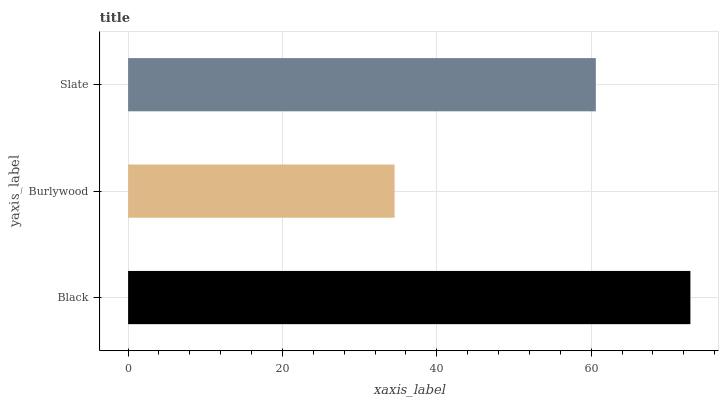Is Burlywood the minimum?
Answer yes or no. Yes. Is Black the maximum?
Answer yes or no. Yes. Is Slate the minimum?
Answer yes or no. No. Is Slate the maximum?
Answer yes or no. No. Is Slate greater than Burlywood?
Answer yes or no. Yes. Is Burlywood less than Slate?
Answer yes or no. Yes. Is Burlywood greater than Slate?
Answer yes or no. No. Is Slate less than Burlywood?
Answer yes or no. No. Is Slate the high median?
Answer yes or no. Yes. Is Slate the low median?
Answer yes or no. Yes. Is Black the high median?
Answer yes or no. No. Is Black the low median?
Answer yes or no. No. 